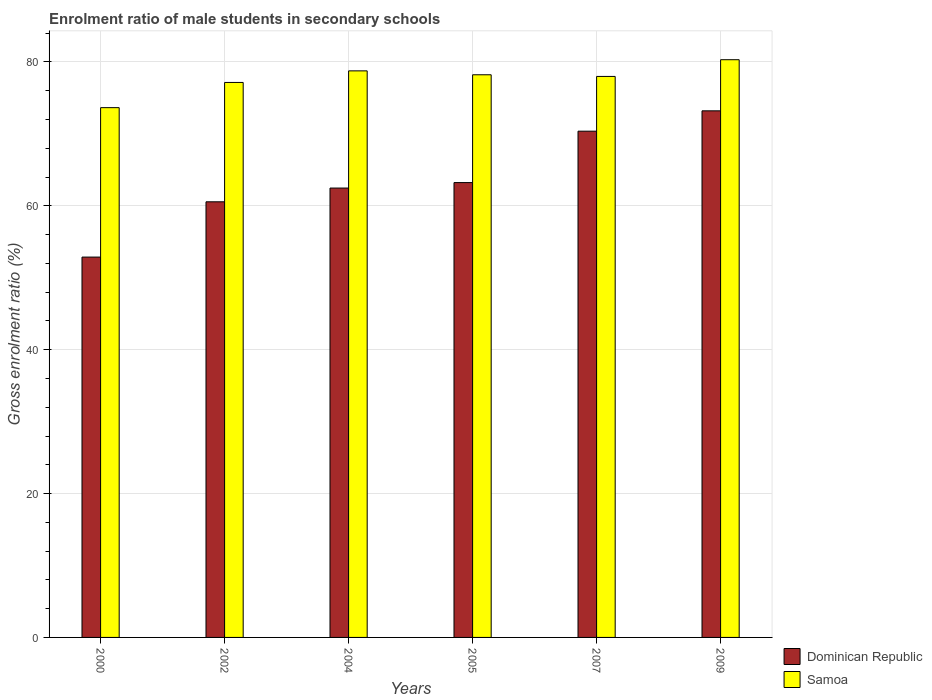Are the number of bars on each tick of the X-axis equal?
Provide a succinct answer. Yes. In how many cases, is the number of bars for a given year not equal to the number of legend labels?
Keep it short and to the point. 0. What is the enrolment ratio of male students in secondary schools in Dominican Republic in 2009?
Keep it short and to the point. 73.21. Across all years, what is the maximum enrolment ratio of male students in secondary schools in Samoa?
Offer a terse response. 80.31. Across all years, what is the minimum enrolment ratio of male students in secondary schools in Samoa?
Offer a terse response. 73.65. In which year was the enrolment ratio of male students in secondary schools in Samoa minimum?
Offer a very short reply. 2000. What is the total enrolment ratio of male students in secondary schools in Samoa in the graph?
Your answer should be compact. 466.09. What is the difference between the enrolment ratio of male students in secondary schools in Samoa in 2000 and that in 2005?
Offer a terse response. -4.57. What is the difference between the enrolment ratio of male students in secondary schools in Samoa in 2007 and the enrolment ratio of male students in secondary schools in Dominican Republic in 2002?
Make the answer very short. 17.43. What is the average enrolment ratio of male students in secondary schools in Dominican Republic per year?
Offer a very short reply. 63.79. In the year 2007, what is the difference between the enrolment ratio of male students in secondary schools in Dominican Republic and enrolment ratio of male students in secondary schools in Samoa?
Provide a succinct answer. -7.61. What is the ratio of the enrolment ratio of male students in secondary schools in Samoa in 2004 to that in 2007?
Offer a very short reply. 1.01. What is the difference between the highest and the second highest enrolment ratio of male students in secondary schools in Samoa?
Make the answer very short. 1.55. What is the difference between the highest and the lowest enrolment ratio of male students in secondary schools in Samoa?
Your answer should be compact. 6.66. Is the sum of the enrolment ratio of male students in secondary schools in Dominican Republic in 2000 and 2007 greater than the maximum enrolment ratio of male students in secondary schools in Samoa across all years?
Your answer should be compact. Yes. What does the 1st bar from the left in 2009 represents?
Your response must be concise. Dominican Republic. What does the 1st bar from the right in 2000 represents?
Your answer should be very brief. Samoa. How many bars are there?
Offer a terse response. 12. Are all the bars in the graph horizontal?
Your answer should be compact. No. Does the graph contain grids?
Your response must be concise. Yes. What is the title of the graph?
Offer a very short reply. Enrolment ratio of male students in secondary schools. Does "Bosnia and Herzegovina" appear as one of the legend labels in the graph?
Ensure brevity in your answer.  No. What is the Gross enrolment ratio (%) in Dominican Republic in 2000?
Offer a very short reply. 52.88. What is the Gross enrolment ratio (%) of Samoa in 2000?
Give a very brief answer. 73.65. What is the Gross enrolment ratio (%) of Dominican Republic in 2002?
Your response must be concise. 60.56. What is the Gross enrolment ratio (%) of Samoa in 2002?
Keep it short and to the point. 77.15. What is the Gross enrolment ratio (%) in Dominican Republic in 2004?
Ensure brevity in your answer.  62.47. What is the Gross enrolment ratio (%) of Samoa in 2004?
Your answer should be compact. 78.76. What is the Gross enrolment ratio (%) of Dominican Republic in 2005?
Give a very brief answer. 63.23. What is the Gross enrolment ratio (%) of Samoa in 2005?
Provide a short and direct response. 78.22. What is the Gross enrolment ratio (%) in Dominican Republic in 2007?
Ensure brevity in your answer.  70.38. What is the Gross enrolment ratio (%) of Samoa in 2007?
Your response must be concise. 77.99. What is the Gross enrolment ratio (%) of Dominican Republic in 2009?
Your answer should be very brief. 73.21. What is the Gross enrolment ratio (%) of Samoa in 2009?
Offer a very short reply. 80.31. Across all years, what is the maximum Gross enrolment ratio (%) of Dominican Republic?
Offer a very short reply. 73.21. Across all years, what is the maximum Gross enrolment ratio (%) of Samoa?
Give a very brief answer. 80.31. Across all years, what is the minimum Gross enrolment ratio (%) of Dominican Republic?
Provide a succinct answer. 52.88. Across all years, what is the minimum Gross enrolment ratio (%) in Samoa?
Make the answer very short. 73.65. What is the total Gross enrolment ratio (%) in Dominican Republic in the graph?
Your response must be concise. 382.73. What is the total Gross enrolment ratio (%) in Samoa in the graph?
Your answer should be very brief. 466.09. What is the difference between the Gross enrolment ratio (%) in Dominican Republic in 2000 and that in 2002?
Provide a succinct answer. -7.69. What is the difference between the Gross enrolment ratio (%) in Samoa in 2000 and that in 2002?
Ensure brevity in your answer.  -3.5. What is the difference between the Gross enrolment ratio (%) of Dominican Republic in 2000 and that in 2004?
Provide a succinct answer. -9.6. What is the difference between the Gross enrolment ratio (%) of Samoa in 2000 and that in 2004?
Your response must be concise. -5.11. What is the difference between the Gross enrolment ratio (%) in Dominican Republic in 2000 and that in 2005?
Your answer should be compact. -10.36. What is the difference between the Gross enrolment ratio (%) in Samoa in 2000 and that in 2005?
Your response must be concise. -4.57. What is the difference between the Gross enrolment ratio (%) in Dominican Republic in 2000 and that in 2007?
Ensure brevity in your answer.  -17.5. What is the difference between the Gross enrolment ratio (%) of Samoa in 2000 and that in 2007?
Ensure brevity in your answer.  -4.34. What is the difference between the Gross enrolment ratio (%) of Dominican Republic in 2000 and that in 2009?
Provide a short and direct response. -20.33. What is the difference between the Gross enrolment ratio (%) of Samoa in 2000 and that in 2009?
Give a very brief answer. -6.66. What is the difference between the Gross enrolment ratio (%) in Dominican Republic in 2002 and that in 2004?
Ensure brevity in your answer.  -1.91. What is the difference between the Gross enrolment ratio (%) in Samoa in 2002 and that in 2004?
Make the answer very short. -1.61. What is the difference between the Gross enrolment ratio (%) in Dominican Republic in 2002 and that in 2005?
Ensure brevity in your answer.  -2.67. What is the difference between the Gross enrolment ratio (%) in Samoa in 2002 and that in 2005?
Your answer should be very brief. -1.07. What is the difference between the Gross enrolment ratio (%) of Dominican Republic in 2002 and that in 2007?
Give a very brief answer. -9.82. What is the difference between the Gross enrolment ratio (%) in Samoa in 2002 and that in 2007?
Your response must be concise. -0.84. What is the difference between the Gross enrolment ratio (%) of Dominican Republic in 2002 and that in 2009?
Provide a short and direct response. -12.65. What is the difference between the Gross enrolment ratio (%) in Samoa in 2002 and that in 2009?
Keep it short and to the point. -3.16. What is the difference between the Gross enrolment ratio (%) in Dominican Republic in 2004 and that in 2005?
Offer a terse response. -0.76. What is the difference between the Gross enrolment ratio (%) of Samoa in 2004 and that in 2005?
Provide a succinct answer. 0.54. What is the difference between the Gross enrolment ratio (%) of Dominican Republic in 2004 and that in 2007?
Your answer should be very brief. -7.91. What is the difference between the Gross enrolment ratio (%) of Samoa in 2004 and that in 2007?
Provide a short and direct response. 0.77. What is the difference between the Gross enrolment ratio (%) in Dominican Republic in 2004 and that in 2009?
Ensure brevity in your answer.  -10.74. What is the difference between the Gross enrolment ratio (%) of Samoa in 2004 and that in 2009?
Offer a very short reply. -1.55. What is the difference between the Gross enrolment ratio (%) of Dominican Republic in 2005 and that in 2007?
Your answer should be compact. -7.15. What is the difference between the Gross enrolment ratio (%) of Samoa in 2005 and that in 2007?
Make the answer very short. 0.23. What is the difference between the Gross enrolment ratio (%) in Dominican Republic in 2005 and that in 2009?
Make the answer very short. -9.98. What is the difference between the Gross enrolment ratio (%) of Samoa in 2005 and that in 2009?
Keep it short and to the point. -2.09. What is the difference between the Gross enrolment ratio (%) of Dominican Republic in 2007 and that in 2009?
Your response must be concise. -2.83. What is the difference between the Gross enrolment ratio (%) in Samoa in 2007 and that in 2009?
Offer a very short reply. -2.32. What is the difference between the Gross enrolment ratio (%) in Dominican Republic in 2000 and the Gross enrolment ratio (%) in Samoa in 2002?
Make the answer very short. -24.28. What is the difference between the Gross enrolment ratio (%) of Dominican Republic in 2000 and the Gross enrolment ratio (%) of Samoa in 2004?
Offer a very short reply. -25.89. What is the difference between the Gross enrolment ratio (%) of Dominican Republic in 2000 and the Gross enrolment ratio (%) of Samoa in 2005?
Provide a succinct answer. -25.35. What is the difference between the Gross enrolment ratio (%) of Dominican Republic in 2000 and the Gross enrolment ratio (%) of Samoa in 2007?
Your answer should be compact. -25.11. What is the difference between the Gross enrolment ratio (%) of Dominican Republic in 2000 and the Gross enrolment ratio (%) of Samoa in 2009?
Keep it short and to the point. -27.44. What is the difference between the Gross enrolment ratio (%) in Dominican Republic in 2002 and the Gross enrolment ratio (%) in Samoa in 2004?
Give a very brief answer. -18.2. What is the difference between the Gross enrolment ratio (%) in Dominican Republic in 2002 and the Gross enrolment ratio (%) in Samoa in 2005?
Your answer should be compact. -17.66. What is the difference between the Gross enrolment ratio (%) of Dominican Republic in 2002 and the Gross enrolment ratio (%) of Samoa in 2007?
Offer a terse response. -17.43. What is the difference between the Gross enrolment ratio (%) in Dominican Republic in 2002 and the Gross enrolment ratio (%) in Samoa in 2009?
Offer a very short reply. -19.75. What is the difference between the Gross enrolment ratio (%) of Dominican Republic in 2004 and the Gross enrolment ratio (%) of Samoa in 2005?
Provide a succinct answer. -15.75. What is the difference between the Gross enrolment ratio (%) of Dominican Republic in 2004 and the Gross enrolment ratio (%) of Samoa in 2007?
Your answer should be very brief. -15.52. What is the difference between the Gross enrolment ratio (%) in Dominican Republic in 2004 and the Gross enrolment ratio (%) in Samoa in 2009?
Give a very brief answer. -17.84. What is the difference between the Gross enrolment ratio (%) in Dominican Republic in 2005 and the Gross enrolment ratio (%) in Samoa in 2007?
Your answer should be compact. -14.76. What is the difference between the Gross enrolment ratio (%) in Dominican Republic in 2005 and the Gross enrolment ratio (%) in Samoa in 2009?
Provide a succinct answer. -17.08. What is the difference between the Gross enrolment ratio (%) in Dominican Republic in 2007 and the Gross enrolment ratio (%) in Samoa in 2009?
Your answer should be compact. -9.94. What is the average Gross enrolment ratio (%) in Dominican Republic per year?
Offer a terse response. 63.79. What is the average Gross enrolment ratio (%) of Samoa per year?
Provide a succinct answer. 77.68. In the year 2000, what is the difference between the Gross enrolment ratio (%) of Dominican Republic and Gross enrolment ratio (%) of Samoa?
Your answer should be compact. -20.77. In the year 2002, what is the difference between the Gross enrolment ratio (%) in Dominican Republic and Gross enrolment ratio (%) in Samoa?
Your answer should be compact. -16.59. In the year 2004, what is the difference between the Gross enrolment ratio (%) of Dominican Republic and Gross enrolment ratio (%) of Samoa?
Make the answer very short. -16.29. In the year 2005, what is the difference between the Gross enrolment ratio (%) of Dominican Republic and Gross enrolment ratio (%) of Samoa?
Your answer should be very brief. -14.99. In the year 2007, what is the difference between the Gross enrolment ratio (%) in Dominican Republic and Gross enrolment ratio (%) in Samoa?
Keep it short and to the point. -7.61. In the year 2009, what is the difference between the Gross enrolment ratio (%) in Dominican Republic and Gross enrolment ratio (%) in Samoa?
Your answer should be compact. -7.11. What is the ratio of the Gross enrolment ratio (%) in Dominican Republic in 2000 to that in 2002?
Give a very brief answer. 0.87. What is the ratio of the Gross enrolment ratio (%) in Samoa in 2000 to that in 2002?
Keep it short and to the point. 0.95. What is the ratio of the Gross enrolment ratio (%) in Dominican Republic in 2000 to that in 2004?
Ensure brevity in your answer.  0.85. What is the ratio of the Gross enrolment ratio (%) of Samoa in 2000 to that in 2004?
Provide a short and direct response. 0.94. What is the ratio of the Gross enrolment ratio (%) in Dominican Republic in 2000 to that in 2005?
Keep it short and to the point. 0.84. What is the ratio of the Gross enrolment ratio (%) of Samoa in 2000 to that in 2005?
Your answer should be compact. 0.94. What is the ratio of the Gross enrolment ratio (%) of Dominican Republic in 2000 to that in 2007?
Make the answer very short. 0.75. What is the ratio of the Gross enrolment ratio (%) of Samoa in 2000 to that in 2007?
Offer a very short reply. 0.94. What is the ratio of the Gross enrolment ratio (%) in Dominican Republic in 2000 to that in 2009?
Your answer should be very brief. 0.72. What is the ratio of the Gross enrolment ratio (%) of Samoa in 2000 to that in 2009?
Make the answer very short. 0.92. What is the ratio of the Gross enrolment ratio (%) in Dominican Republic in 2002 to that in 2004?
Make the answer very short. 0.97. What is the ratio of the Gross enrolment ratio (%) of Samoa in 2002 to that in 2004?
Provide a succinct answer. 0.98. What is the ratio of the Gross enrolment ratio (%) in Dominican Republic in 2002 to that in 2005?
Provide a short and direct response. 0.96. What is the ratio of the Gross enrolment ratio (%) in Samoa in 2002 to that in 2005?
Your response must be concise. 0.99. What is the ratio of the Gross enrolment ratio (%) in Dominican Republic in 2002 to that in 2007?
Offer a terse response. 0.86. What is the ratio of the Gross enrolment ratio (%) of Samoa in 2002 to that in 2007?
Ensure brevity in your answer.  0.99. What is the ratio of the Gross enrolment ratio (%) of Dominican Republic in 2002 to that in 2009?
Provide a short and direct response. 0.83. What is the ratio of the Gross enrolment ratio (%) of Samoa in 2002 to that in 2009?
Keep it short and to the point. 0.96. What is the ratio of the Gross enrolment ratio (%) of Dominican Republic in 2004 to that in 2007?
Provide a short and direct response. 0.89. What is the ratio of the Gross enrolment ratio (%) in Samoa in 2004 to that in 2007?
Ensure brevity in your answer.  1.01. What is the ratio of the Gross enrolment ratio (%) of Dominican Republic in 2004 to that in 2009?
Your answer should be compact. 0.85. What is the ratio of the Gross enrolment ratio (%) in Samoa in 2004 to that in 2009?
Provide a succinct answer. 0.98. What is the ratio of the Gross enrolment ratio (%) of Dominican Republic in 2005 to that in 2007?
Your answer should be compact. 0.9. What is the ratio of the Gross enrolment ratio (%) in Dominican Republic in 2005 to that in 2009?
Provide a succinct answer. 0.86. What is the ratio of the Gross enrolment ratio (%) in Samoa in 2005 to that in 2009?
Ensure brevity in your answer.  0.97. What is the ratio of the Gross enrolment ratio (%) in Dominican Republic in 2007 to that in 2009?
Keep it short and to the point. 0.96. What is the ratio of the Gross enrolment ratio (%) in Samoa in 2007 to that in 2009?
Offer a terse response. 0.97. What is the difference between the highest and the second highest Gross enrolment ratio (%) of Dominican Republic?
Provide a succinct answer. 2.83. What is the difference between the highest and the second highest Gross enrolment ratio (%) in Samoa?
Provide a succinct answer. 1.55. What is the difference between the highest and the lowest Gross enrolment ratio (%) of Dominican Republic?
Provide a succinct answer. 20.33. What is the difference between the highest and the lowest Gross enrolment ratio (%) of Samoa?
Provide a succinct answer. 6.66. 